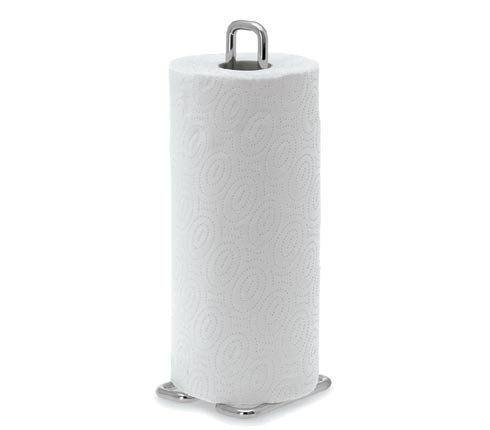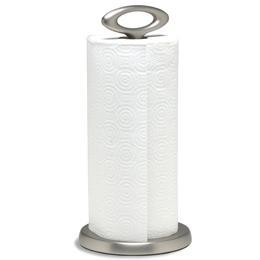The first image is the image on the left, the second image is the image on the right. Given the left and right images, does the statement "In one image, a stack of folded paper towels is angled so the narrow end of the stack is visible, and one paper towel is displayed partially opened." hold true? Answer yes or no. No. The first image is the image on the left, the second image is the image on the right. For the images shown, is this caption "At least one image shows an upright roll of white towels on a stand." true? Answer yes or no. Yes. 